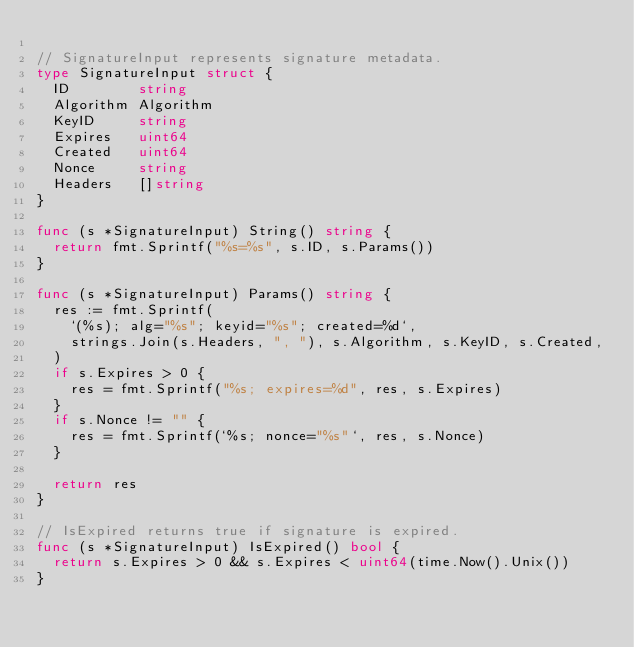Convert code to text. <code><loc_0><loc_0><loc_500><loc_500><_Go_>
// SignatureInput represents signature metadata.
type SignatureInput struct {
	ID        string
	Algorithm Algorithm
	KeyID     string
	Expires   uint64
	Created   uint64
	Nonce     string
	Headers   []string
}

func (s *SignatureInput) String() string {
	return fmt.Sprintf("%s=%s", s.ID, s.Params())
}

func (s *SignatureInput) Params() string {
	res := fmt.Sprintf(
		`(%s); alg="%s"; keyid="%s"; created=%d`,
		strings.Join(s.Headers, ", "), s.Algorithm, s.KeyID, s.Created,
	)
	if s.Expires > 0 {
		res = fmt.Sprintf("%s; expires=%d", res, s.Expires)
	}
	if s.Nonce != "" {
		res = fmt.Sprintf(`%s; nonce="%s"`, res, s.Nonce)
	}

	return res
}

// IsExpired returns true if signature is expired.
func (s *SignatureInput) IsExpired() bool {
	return s.Expires > 0 && s.Expires < uint64(time.Now().Unix())
}
</code> 